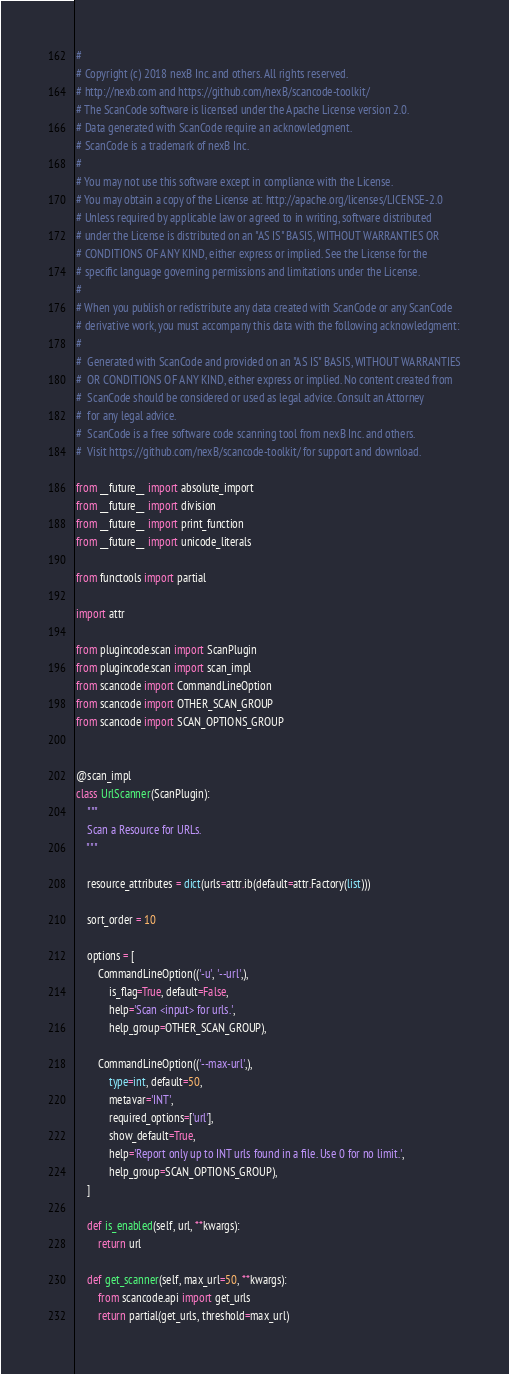Convert code to text. <code><loc_0><loc_0><loc_500><loc_500><_Python_>#
# Copyright (c) 2018 nexB Inc. and others. All rights reserved.
# http://nexb.com and https://github.com/nexB/scancode-toolkit/
# The ScanCode software is licensed under the Apache License version 2.0.
# Data generated with ScanCode require an acknowledgment.
# ScanCode is a trademark of nexB Inc.
#
# You may not use this software except in compliance with the License.
# You may obtain a copy of the License at: http://apache.org/licenses/LICENSE-2.0
# Unless required by applicable law or agreed to in writing, software distributed
# under the License is distributed on an "AS IS" BASIS, WITHOUT WARRANTIES OR
# CONDITIONS OF ANY KIND, either express or implied. See the License for the
# specific language governing permissions and limitations under the License.
#
# When you publish or redistribute any data created with ScanCode or any ScanCode
# derivative work, you must accompany this data with the following acknowledgment:
#
#  Generated with ScanCode and provided on an "AS IS" BASIS, WITHOUT WARRANTIES
#  OR CONDITIONS OF ANY KIND, either express or implied. No content created from
#  ScanCode should be considered or used as legal advice. Consult an Attorney
#  for any legal advice.
#  ScanCode is a free software code scanning tool from nexB Inc. and others.
#  Visit https://github.com/nexB/scancode-toolkit/ for support and download.

from __future__ import absolute_import
from __future__ import division
from __future__ import print_function
from __future__ import unicode_literals

from functools import partial

import attr

from plugincode.scan import ScanPlugin
from plugincode.scan import scan_impl
from scancode import CommandLineOption
from scancode import OTHER_SCAN_GROUP
from scancode import SCAN_OPTIONS_GROUP


@scan_impl
class UrlScanner(ScanPlugin):
    """
    Scan a Resource for URLs.
    """

    resource_attributes = dict(urls=attr.ib(default=attr.Factory(list)))

    sort_order = 10

    options = [
        CommandLineOption(('-u', '--url',),
            is_flag=True, default=False,
            help='Scan <input> for urls.',
            help_group=OTHER_SCAN_GROUP),

        CommandLineOption(('--max-url',),
            type=int, default=50,
            metavar='INT',
            required_options=['url'],
            show_default=True,
            help='Report only up to INT urls found in a file. Use 0 for no limit.',
            help_group=SCAN_OPTIONS_GROUP),
    ]

    def is_enabled(self, url, **kwargs):
        return url

    def get_scanner(self, max_url=50, **kwargs):
        from scancode.api import get_urls
        return partial(get_urls, threshold=max_url)
</code> 